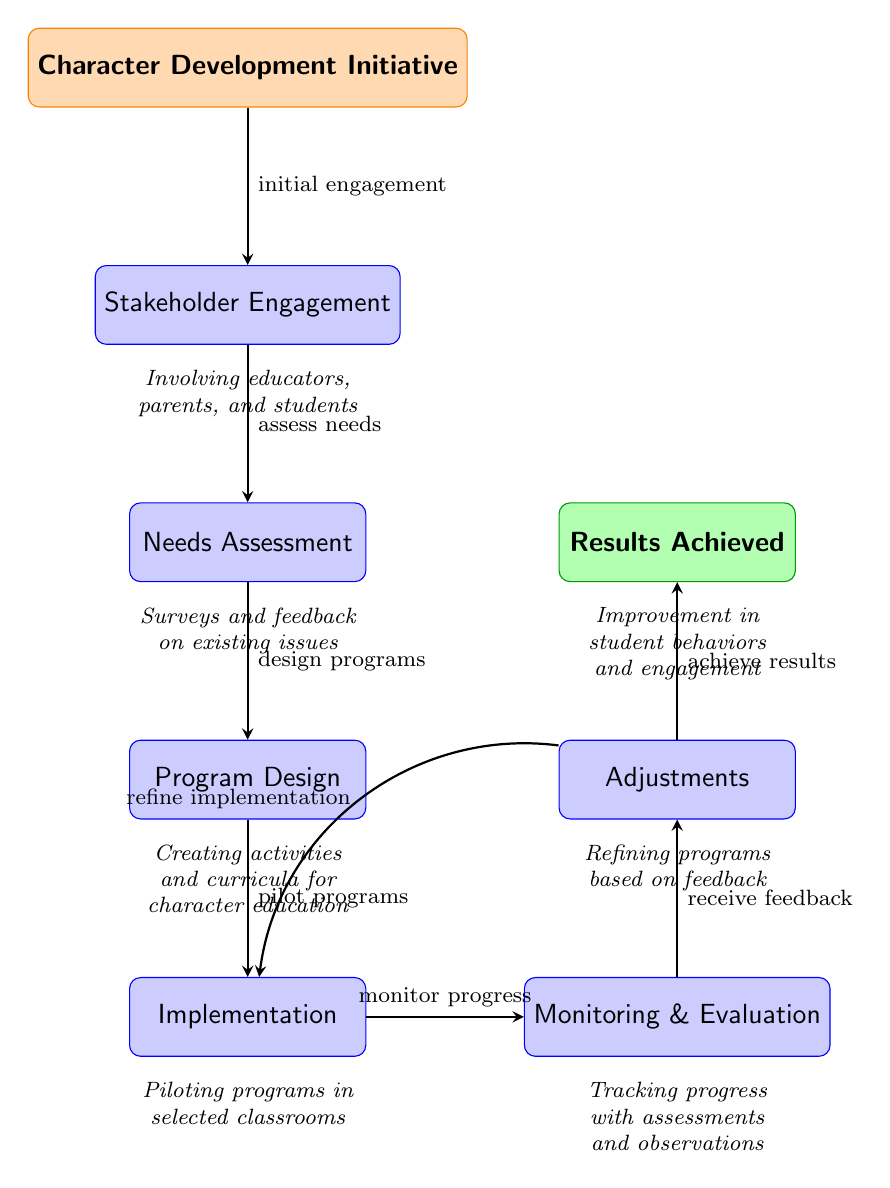What is the first step in the character development initiative? The diagram indicates that the first step is labeled "Character Development Initiative." This is at the top of the flow and serves as the starting point.
Answer: Character Development Initiative How many nodes are present in the diagram? By counting the distinct stages represented, we identify seven nodes: the initial initiative, stakeholder engagement, needs assessment, program design, implementation, monitoring & evaluation, adjustments, and results achieved.
Answer: Seven Which node follows the "Program Design" stage? Following "Program Design," the next node shown in the flow is "Implementation." This relationship is clearly indicated by the arrow connecting these two nodes.
Answer: Implementation What happens after "Monitoring & Evaluation"? After "Monitoring & Evaluation," the next action depicted is "Adjustments," which is shown to be connected directly to the monitoring and evaluation stage.
Answer: Adjustments What is the relationship between "Adjustments" and "Implementation"? The diagram illustrates a feedback loop where "Adjustments" leads back to "Implementation," indicating that refinements will be made to the implementation process based on feedback received during evaluation.
Answer: Refine implementation What type of feedback is collected during the "Monitoring & Evaluation" step? The monitoring and evaluation process focuses on tracking progress through assessments and observations, leading to information that helps form the adjustments needed in the initiative.
Answer: Assessments and observations What improvement is expected as a result of the entire initiative? The results achieved at the end of the journey map indicate an improvement in student behaviors and engagement, which is the ultimate goal of the character development initiative.
Answer: Improvement in student behaviors and engagement 